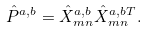<formula> <loc_0><loc_0><loc_500><loc_500>\hat { P } ^ { a , b } = \hat { X } ^ { a , b } _ { m n } \hat { X } ^ { a , b T } _ { m n } .</formula> 